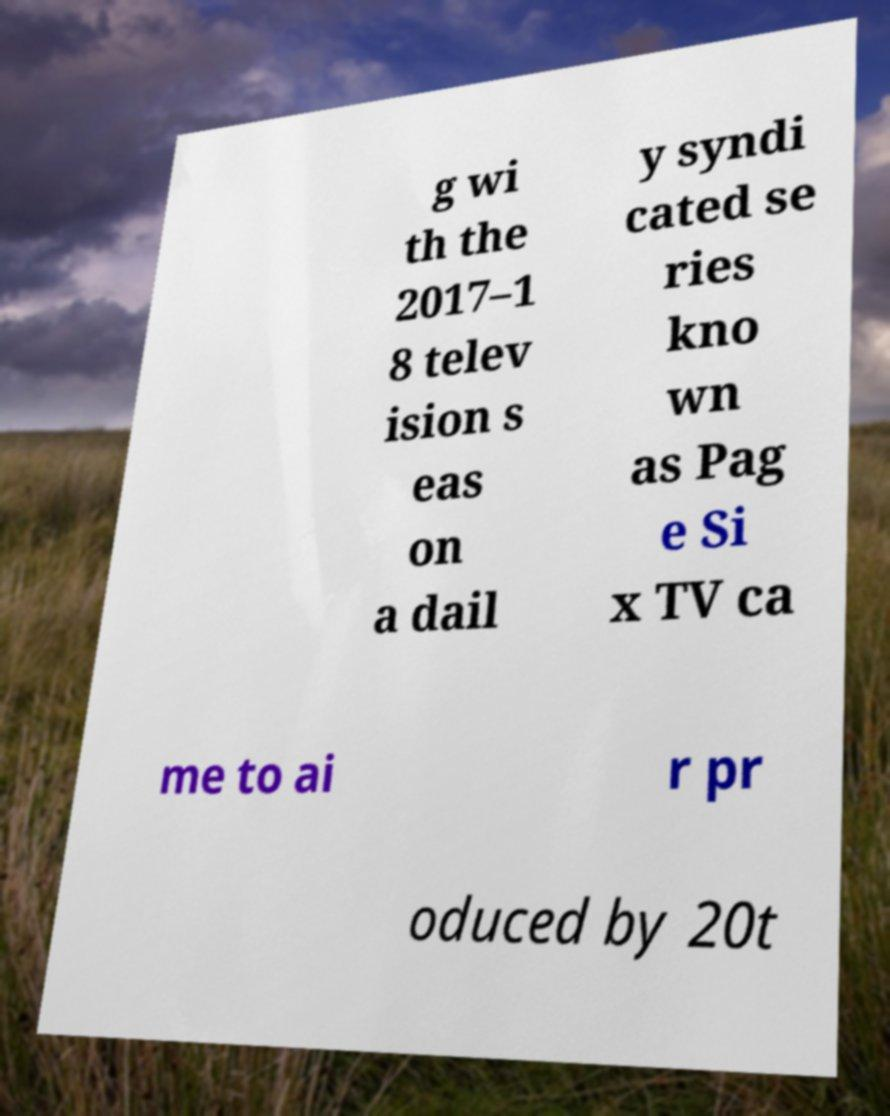Could you assist in decoding the text presented in this image and type it out clearly? g wi th the 2017–1 8 telev ision s eas on a dail y syndi cated se ries kno wn as Pag e Si x TV ca me to ai r pr oduced by 20t 